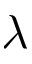<formula> <loc_0><loc_0><loc_500><loc_500>\lambda</formula> 